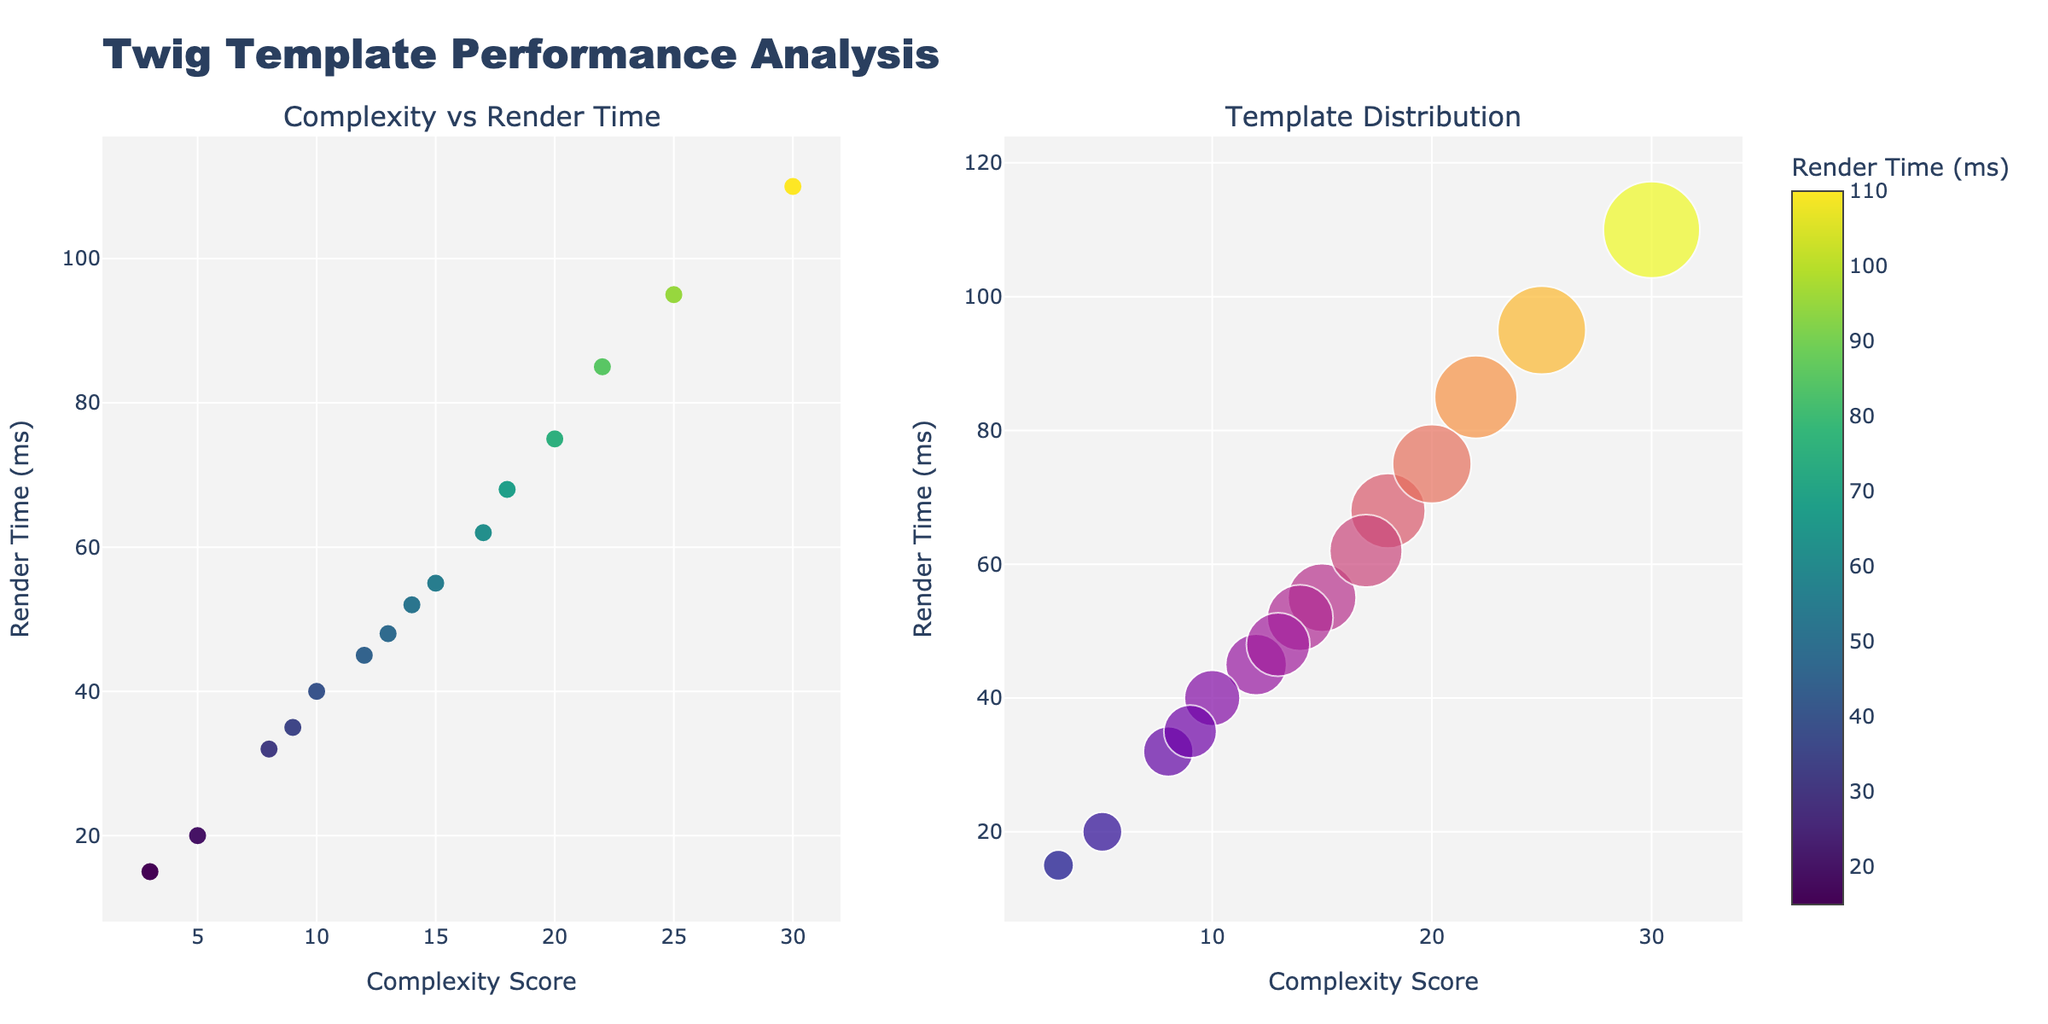What does the title of the figure say? The title is prominently displayed at the top of the figure. It states the overall purpose of the plots.
Answer: Twig Template Performance Analysis What does the x-axis represent in the first subplot? The label of the x-axis in the first subplot indicates the metric that is being measured horizontally.
Answer: Complexity Score How many templates are being analyzed in total? Count the number of data points (markers) in either subplot. Each marker corresponds to a template. There are 15 templates listed in the provided data.
Answer: 15 Which template has the highest render time, and what is its render time? Look for the marker placed furthest to the top on the y-axis in the first subplot. Hover over it to see the template name and render time. The "admin_panel" has the highest render time of 110 ms.
Answer: admin_panel, 110 ms What is the template with the lowest complexity score? In the first subplot, find the marker positioned furthest to the left on the x-axis. Hover over it to see the template name.
Answer: footer_template Explain the trend you observe between complexity score and render time. The markers generally show an upward trend from left to right, indicating that as the complexity score increases, the render time tends to increase as well.
Answer: As complexity increases, render time usually increases Which template appears to be an outlier in terms of complexity score? Identify the marker furthest to the right as it represents the highest complexity score.
Answer: admin_panel Compare the render time of “checkout_form” and “search_results”. Which is faster? Locate both markers based on their template names. Check their respective positions on the y-axis. The "search_results" marker is lower on the y-axis, indicating it has a lower (faster) render time than "checkout_form".
Answer: search_results Considering both subplots, describe the relationship between marker size and render time in the second subplot. In the second subplot (bubble plot), larger markers represent higher complexity scores, not render times. However, larger marks are generally more colorful, and color intensity (darker shade) represents higher render time.
Answer: Marker size reflects complexity, color intensity reflects render time What is the average render time for all templates? Sum all render times from the data given and divide by the number of templates. Sum = 45 + 32 + 68 + 55 + 85 + 110 + 75 + 20 + 15 + 40 + 52 + 95 + 62 + 48 + 35 = 837. Average = 837 / 15.
Answer: 55.8 ms 